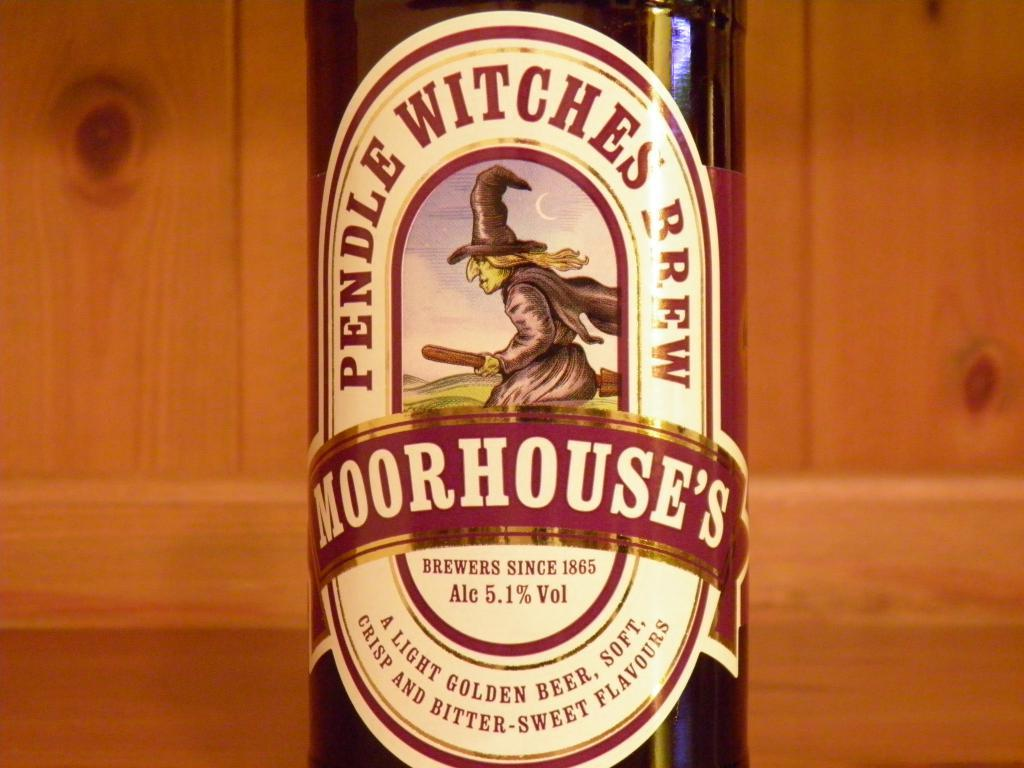<image>
Create a compact narrative representing the image presented. a wine bottle called 'moorhouse's' with alc 5.1% vol 